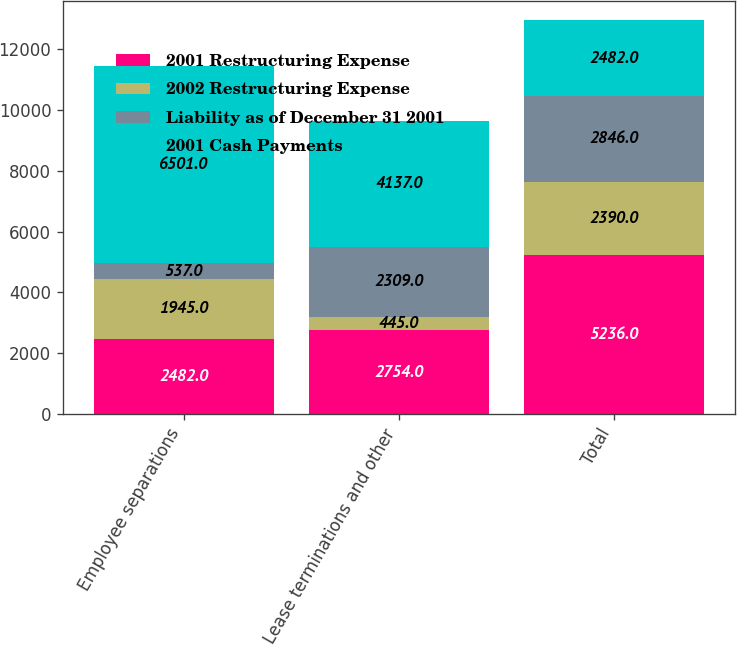<chart> <loc_0><loc_0><loc_500><loc_500><stacked_bar_chart><ecel><fcel>Employee separations<fcel>Lease terminations and other<fcel>Total<nl><fcel>2001 Restructuring Expense<fcel>2482<fcel>2754<fcel>5236<nl><fcel>2002 Restructuring Expense<fcel>1945<fcel>445<fcel>2390<nl><fcel>Liability as of December 31 2001<fcel>537<fcel>2309<fcel>2846<nl><fcel>2001 Cash Payments<fcel>6501<fcel>4137<fcel>2482<nl></chart> 